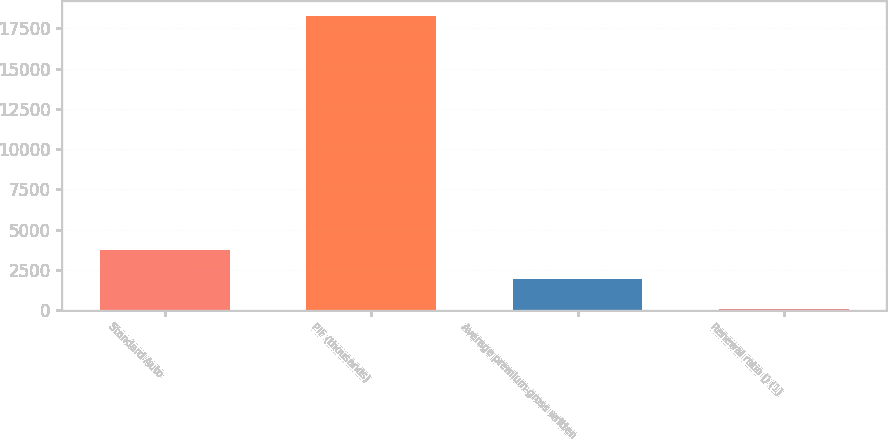Convert chart to OTSL. <chart><loc_0><loc_0><loc_500><loc_500><bar_chart><fcel>Standard Auto<fcel>PIF (thousands)<fcel>Average premium-gross written<fcel>Renewal ratio () (1)<nl><fcel>3722.8<fcel>18256<fcel>1906.15<fcel>89.5<nl></chart> 